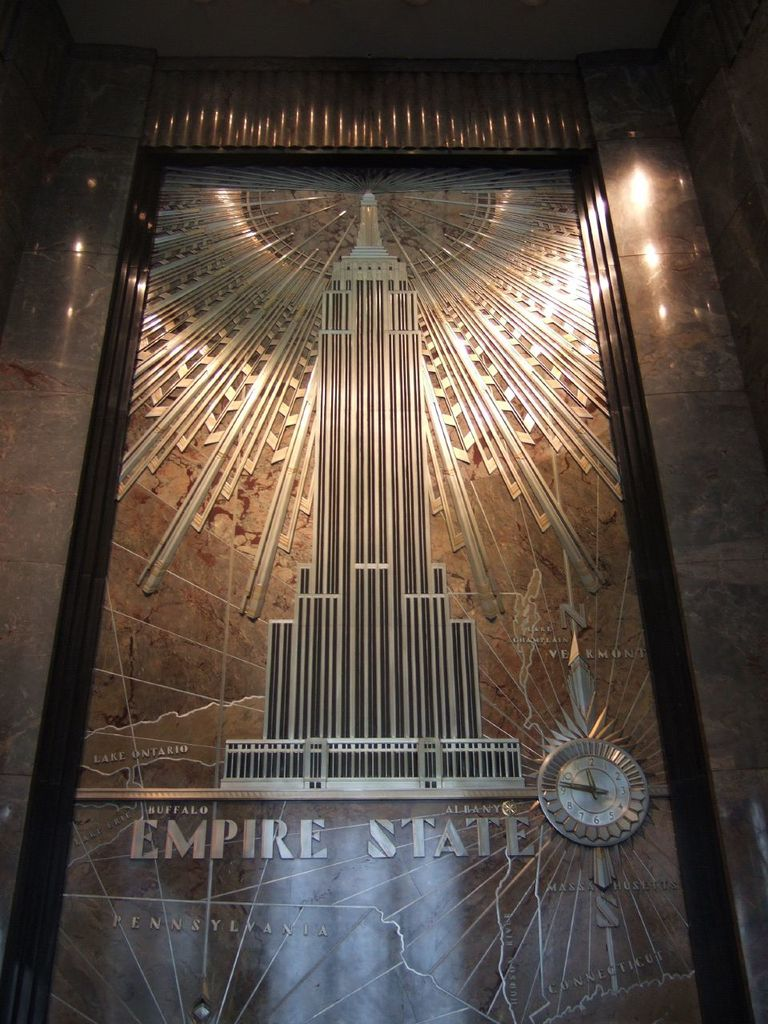Can you explain the significance of the map and clock featured in the image? The map and clock in the image serve both functional and decorative purposes; they highlight major New York cities and the central position of the Empire State Building, symbolizing its historical and cultural significance in the region. What other details can be observed that enhance the thematic consistency of this artwork? Apart from the Empire State Building, the artwork includes elements like radiating lines emanating from the structure, symbolizing its towering influence and the art deco style's focus on dynamism and the futuristic aspects of the early 20th century. 